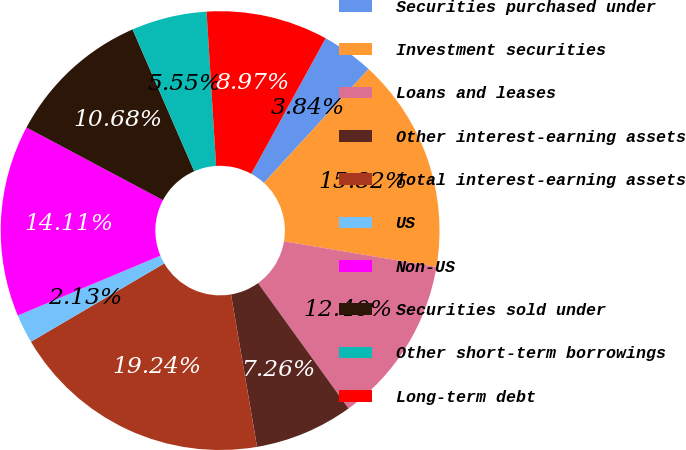Convert chart to OTSL. <chart><loc_0><loc_0><loc_500><loc_500><pie_chart><fcel>Securities purchased under<fcel>Investment securities<fcel>Loans and leases<fcel>Other interest-earning assets<fcel>Total interest-earning assets<fcel>US<fcel>Non-US<fcel>Securities sold under<fcel>Other short-term borrowings<fcel>Long-term debt<nl><fcel>3.84%<fcel>15.82%<fcel>12.4%<fcel>7.26%<fcel>19.24%<fcel>2.13%<fcel>14.11%<fcel>10.68%<fcel>5.55%<fcel>8.97%<nl></chart> 